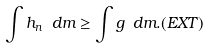<formula> <loc_0><loc_0><loc_500><loc_500>\int h _ { n } \text { } d m \geq \int g \text { } d m . ( E X T )</formula> 